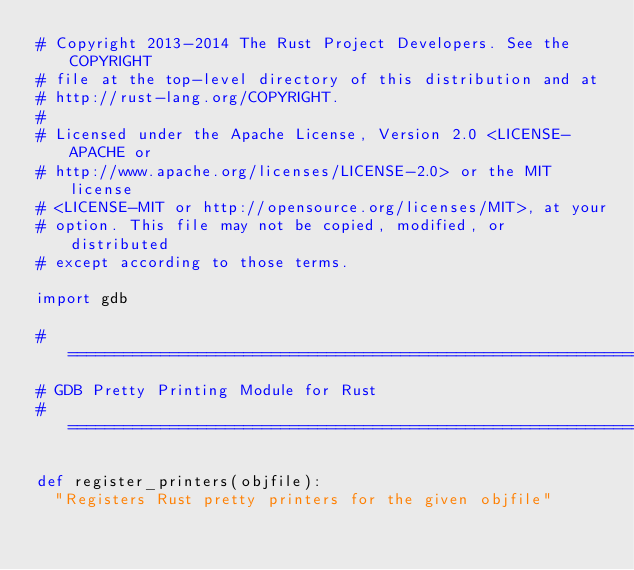<code> <loc_0><loc_0><loc_500><loc_500><_Python_># Copyright 2013-2014 The Rust Project Developers. See the COPYRIGHT
# file at the top-level directory of this distribution and at
# http://rust-lang.org/COPYRIGHT.
#
# Licensed under the Apache License, Version 2.0 <LICENSE-APACHE or
# http://www.apache.org/licenses/LICENSE-2.0> or the MIT license
# <LICENSE-MIT or http://opensource.org/licenses/MIT>, at your
# option. This file may not be copied, modified, or distributed
# except according to those terms.

import gdb

#===============================================================================
# GDB Pretty Printing Module for Rust
#===============================================================================

def register_printers(objfile):
  "Registers Rust pretty printers for the given objfile"</code> 